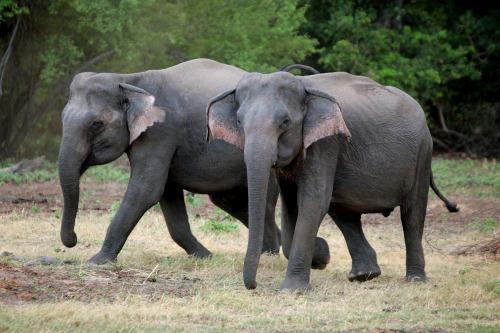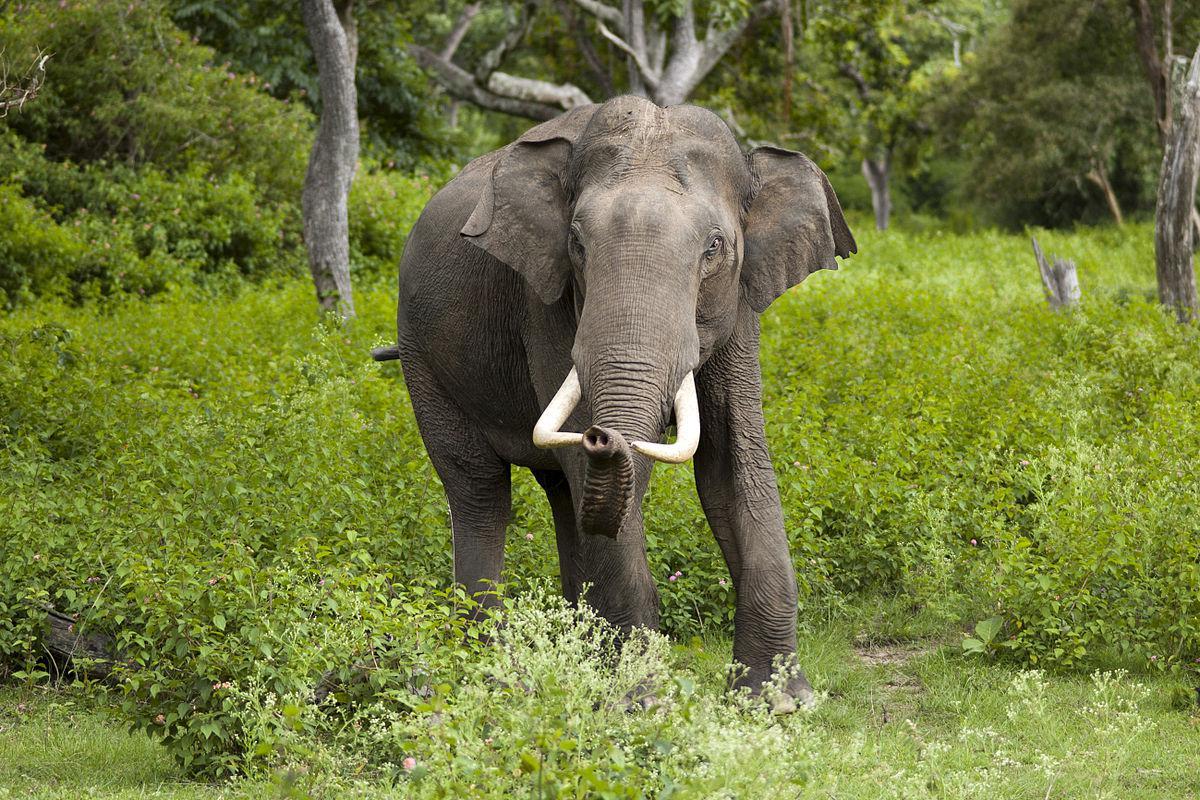The first image is the image on the left, the second image is the image on the right. Considering the images on both sides, is "Left and right images depict one elephant, which has tusks." valid? Answer yes or no. No. The first image is the image on the left, the second image is the image on the right. For the images displayed, is the sentence "Exactly one adult elephant with long, white ivory tusks is depicted in each image." factually correct? Answer yes or no. No. 